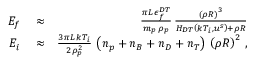<formula> <loc_0><loc_0><loc_500><loc_500>\begin{array} { r l r } { E _ { f } } & \approx } & { \frac { \pi L \, \epsilon _ { f } ^ { D T } } { m _ { p } \, \rho _ { p } } \, \frac { \left ( \rho R \right ) ^ { 3 } } { H _ { D T } \left ( k T _ { i } , u ^ { s } \right ) + \rho R } } \\ { E _ { i } } & \approx } & { \frac { 3 \pi L \, k T _ { i } } { 2 \rho _ { p } ^ { 2 } } \, \left ( n _ { p } + n _ { B } + n _ { D } + n _ { T } \right ) \, \left ( \rho R \right ) ^ { 2 } \, , } \end{array}</formula> 